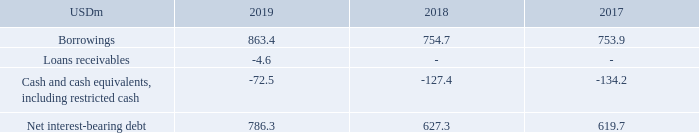ALTERNATIVE PERFORMANCE MEASURES
Net interest-bearing debt:
Net interest-bearing debt is defined as borrowings (current and noncurrent) less loans receivables and cash and cash equivalents, including restricted cash. Net interest-bearing debt depicts the net capital resources, which cause net interest expenditure and interest rate risk and which, together with equity, are used to finance the Company’s investments. As such, TORM believes that net interest-bearing debt is a relevant measure which Management uses to measure the overall development of the use of financing, other than equity. Such measure may not be comparable to similarly titled measures of other companies. Net interest-bearing debt is calculated as follows:
How is net interest-bearing debt defined? Borrowings (current and noncurrent) less loans receivables and cash and cash equivalents, including restricted cash. What does TORM believe net interest-bearing debt to be? A relevant measure which management uses to measure the overall development of the use of financing, other than equity. What are the components used to calculate net interest-bearing debt in the table? Borrowings, loans receivables, cash and cash equivalents, including restricted cash. In which year was the amount of Borrowings the lowest? 753.9<754.7<863.4
Answer: 2017. What was the change in Net interest-bearing debt in 2019 from 2018?
Answer scale should be: million. 786.3-627.3
Answer: 159. What was the percentage change in Net interest-bearing debt in 2019 from 2018?
Answer scale should be: percent. (786.3-627.3)/627.3
Answer: 25.35. 